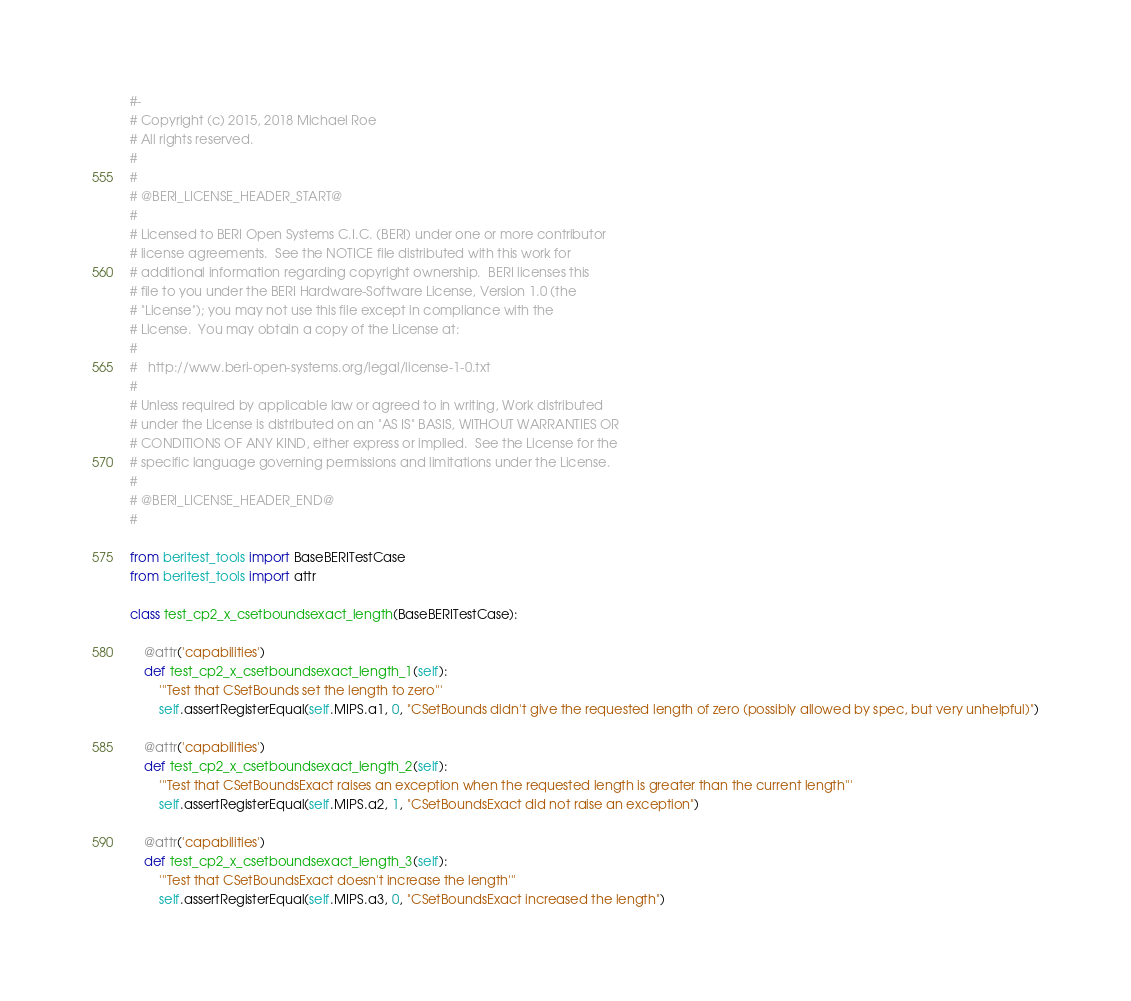Convert code to text. <code><loc_0><loc_0><loc_500><loc_500><_Python_>#-
# Copyright (c) 2015, 2018 Michael Roe
# All rights reserved.
#
#
# @BERI_LICENSE_HEADER_START@
#
# Licensed to BERI Open Systems C.I.C. (BERI) under one or more contributor
# license agreements.  See the NOTICE file distributed with this work for
# additional information regarding copyright ownership.  BERI licenses this
# file to you under the BERI Hardware-Software License, Version 1.0 (the
# "License"); you may not use this file except in compliance with the
# License.  You may obtain a copy of the License at:
#
#   http://www.beri-open-systems.org/legal/license-1-0.txt
#
# Unless required by applicable law or agreed to in writing, Work distributed
# under the License is distributed on an "AS IS" BASIS, WITHOUT WARRANTIES OR
# CONDITIONS OF ANY KIND, either express or implied.  See the License for the
# specific language governing permissions and limitations under the License.
#
# @BERI_LICENSE_HEADER_END@
#

from beritest_tools import BaseBERITestCase
from beritest_tools import attr

class test_cp2_x_csetboundsexact_length(BaseBERITestCase):

    @attr('capabilities')
    def test_cp2_x_csetboundsexact_length_1(self):
        '''Test that CSetBounds set the length to zero'''
        self.assertRegisterEqual(self.MIPS.a1, 0, "CSetBounds didn't give the requested length of zero (possibly allowed by spec, but very unhelpful)")

    @attr('capabilities')
    def test_cp2_x_csetboundsexact_length_2(self):
        '''Test that CSetBoundsExact raises an exception when the requested length is greater than the current length'''
        self.assertRegisterEqual(self.MIPS.a2, 1, "CSetBoundsExact did not raise an exception")

    @attr('capabilities')
    def test_cp2_x_csetboundsexact_length_3(self):
        '''Test that CSetBoundsExact doesn't increase the length'''
        self.assertRegisterEqual(self.MIPS.a3, 0, "CSetBoundsExact increased the length")

</code> 